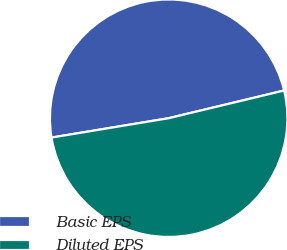Convert chart to OTSL. <chart><loc_0><loc_0><loc_500><loc_500><pie_chart><fcel>Basic EPS<fcel>Diluted EPS<nl><fcel>48.86%<fcel>51.14%<nl></chart> 